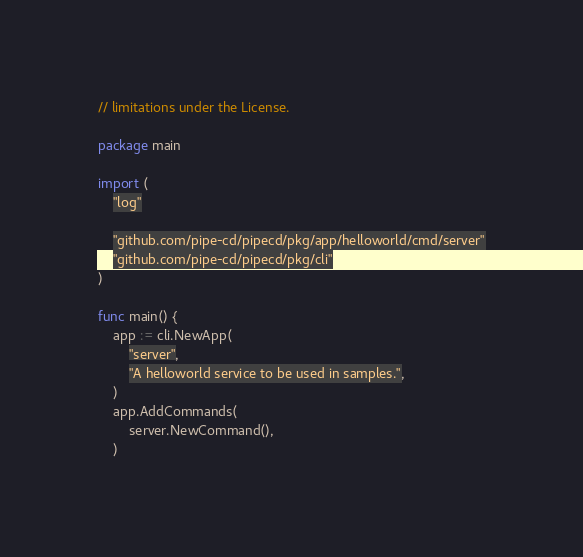<code> <loc_0><loc_0><loc_500><loc_500><_Go_>// limitations under the License.

package main

import (
	"log"

	"github.com/pipe-cd/pipecd/pkg/app/helloworld/cmd/server"
	"github.com/pipe-cd/pipecd/pkg/cli"
)

func main() {
	app := cli.NewApp(
		"server",
		"A helloworld service to be used in samples.",
	)
	app.AddCommands(
		server.NewCommand(),
	)</code> 